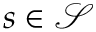<formula> <loc_0><loc_0><loc_500><loc_500>s \in \mathcal { S }</formula> 